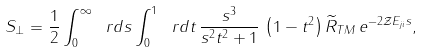Convert formula to latex. <formula><loc_0><loc_0><loc_500><loc_500>S _ { \perp } = \frac { 1 } { 2 } \int _ { 0 } ^ { \infty } \ r d s \int _ { 0 } ^ { 1 } \ r d t \, \frac { s ^ { 3 } } { s ^ { 2 } t ^ { 2 } + 1 } \, \left ( 1 - t ^ { 2 } \right ) \widetilde { R } _ { T M } \, e ^ { - 2 \mathcal { Z } E _ { j i } s } ,</formula> 